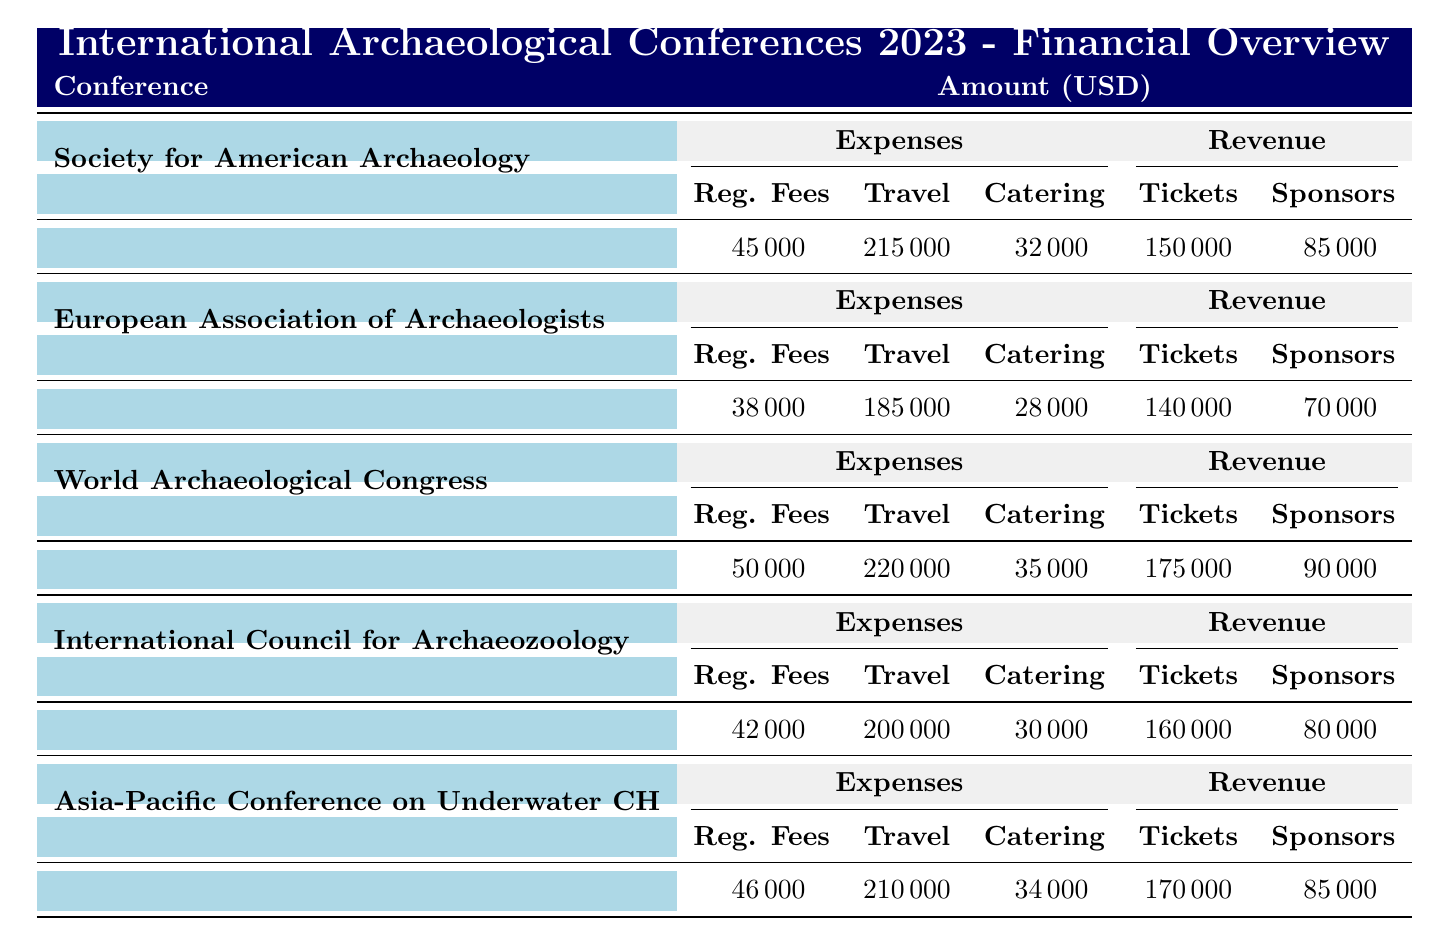What is the total revenue generated from the Society for American Archaeology Annual Meeting? The revenue is made up of Ticket Sales (150000), Sponsorships (85000), Grant Funding (60000), Merchandise Sales (4500), and Publication Sales (3500). Adding these together gives 150000 + 85000 + 60000 + 4500 + 3500 = 296000.
Answer: 296000 What are the registration fees for the World Archaeological Congress? The registration fees are specified in the table directly under the World Archaeological Congress section, which is 50000.
Answer: 50000 Is the total expense for the Asia-Pacific Conference on Underwater Cultural Heritage greater than 400000? To determine this, sum up the expenses: Registration Fees (46000) + Travel and Accommodation (210000) + Catering (34000) + Venue Rental (15500) + Marketing (9200) + Miscellaneous (6400) equals 46000 + 210000 + 34000 + 15500 + 9200 + 6400 = 296100, which is less than 400000.
Answer: No What is the average catering expense across all conferences? The catering expenses for each conference are: Society for American Archaeology (32000), European Association of Archaeologists (28000), World Archaeological Congress (35000), International Council for Archaeozoology (30000), and Asia-Pacific Conference on Underwater Cultural Heritage (34000). Adding these gives 32000 + 28000 + 35000 + 30000 + 34000 = 159000. To find the average, divide by the number of conferences (5): 159000 / 5 = 31800.
Answer: 31800 Which conference had the highest total expenses? First, sum the expenses for each conference: Society for American Archaeology (45000 + 215000 + 32000 + 12000 + 8000 + 5000 = 296000), European Association of Archaeologists (38000 + 185000 + 28000 + 16500 + 9000 + 4500 = 258000), World Archaeological Congress (50000 + 220000 + 35000 + 18000 + 10000 + 6000 = 333000), International Council for Archaeozoology (42000 + 200000 + 30000 + 14000 + 8500 + 5500 = 276000), Asia-Pacific Conference on Underwater Cultural Heritage (46000 + 210000 + 34000 + 15500 + 9200 + 6400 = 296100). The highest total among these is World Archaeological Congress at 333000.
Answer: World Archaeological Congress What is the total amount earned through Grant Funding at the International Council for Archaeozoology Conference? The amount for Grant Funding listed under the International Council for Archaeozoology Conference is 60000.
Answer: 60000 